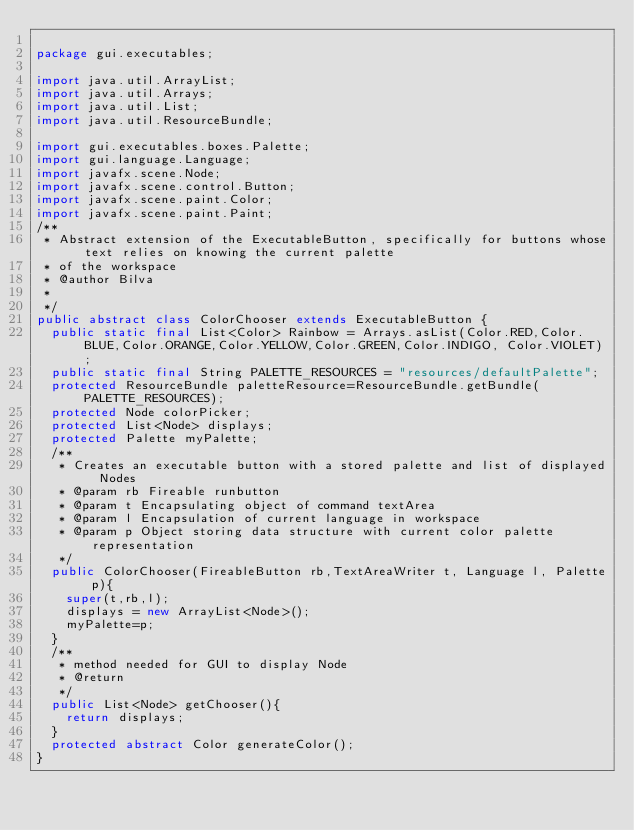Convert code to text. <code><loc_0><loc_0><loc_500><loc_500><_Java_>
package gui.executables;

import java.util.ArrayList;
import java.util.Arrays;
import java.util.List;
import java.util.ResourceBundle;

import gui.executables.boxes.Palette;
import gui.language.Language;
import javafx.scene.Node;
import javafx.scene.control.Button;
import javafx.scene.paint.Color;
import javafx.scene.paint.Paint;
/**
 * Abstract extension of the ExecutableButton, specifically for buttons whose text relies on knowing the current palette
 * of the workspace
 * @author Bilva
 *
 */
public abstract class ColorChooser extends ExecutableButton {
	public static final List<Color> Rainbow = Arrays.asList(Color.RED,Color.BLUE,Color.ORANGE,Color.YELLOW,Color.GREEN,Color.INDIGO, Color.VIOLET);
	public static final String PALETTE_RESOURCES = "resources/defaultPalette";
	protected ResourceBundle paletteResource=ResourceBundle.getBundle(PALETTE_RESOURCES);
	protected Node colorPicker;
	protected List<Node> displays;
	protected Palette myPalette;
	/**
	 * Creates an executable button with a stored palette and list of displayed Nodes
	 * @param rb Fireable runbutton
	 * @param t Encapsulating object of command textArea
	 * @param l Encapsulation of current language in workspace
	 * @param p Object storing data structure with current color palette representation
	 */
	public ColorChooser(FireableButton rb,TextAreaWriter t, Language l, Palette p){
		super(t,rb,l);
		displays = new ArrayList<Node>();
		myPalette=p;
	}
	/**
	 * method needed for GUI to display Node
	 * @return
	 */
	public List<Node> getChooser(){
		return displays;
	}
	protected abstract Color generateColor();
}
</code> 